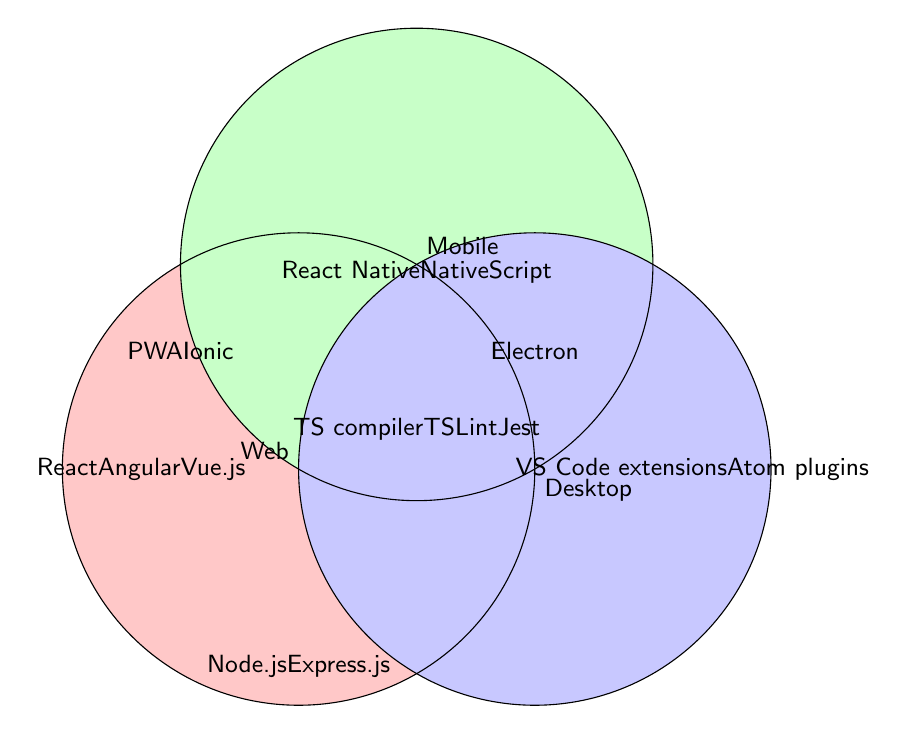Which project types include the TypeScript compiler? The TypeScript compiler appears in the central region where all three circles (Web, Mobile, and Desktop) overlap.
Answer: Web, Mobile, and Desktop What features are unique to desktop projects? The unique features for desktop projects are found in the section where only the desktop circle exists without overlapping with the web or mobile circles.
Answer: VS Code extensions and Atom plugins How many features are common to both web and mobile projects? The features common to both web and mobile projects are listed in the area where the web and mobile circles overlap but not with the desktop circle.
Answer: Two Which project types support Progressive Web Apps? Progressive Web Apps are found in the overlapping area between the web and mobile circles.
Answer: Web and Mobile Which project type has the most features? To determine which project type has the most features, count the number of items in each circle individually. The web circle contains React, Angular, Vue.js, PWA, Ionic, Node.js, Express.js, Electron, TS compiler, TSLint, and Jest, totaling eleven. Similarly, Mobile contains six, and Desktop contains six.
Answer: Web What features belong to all three project types? The features that belong to all three project types are listed in the central area where all three circles (Web, Mobile, and Desktop) overlap.
Answer: TS compiler, TSLint, and Jest Which feature is shared between web and desktop projects but not mobile projects? To identify the shared feature between web and desktop but not mobile, look at the section where the web and desktop circles overlap without touching the mobile circle.
Answer: Node.js and Express.js Is there any feature unique to web projects? Features unique to web projects are listed within the web circle but outside any overlapping area with mobile or desktop.
Answer: React, Angular, and Vue.js How many total features are there in the diagram? Count all the unique features listed across the entire Venn diagram.
Answer: Thirteen 